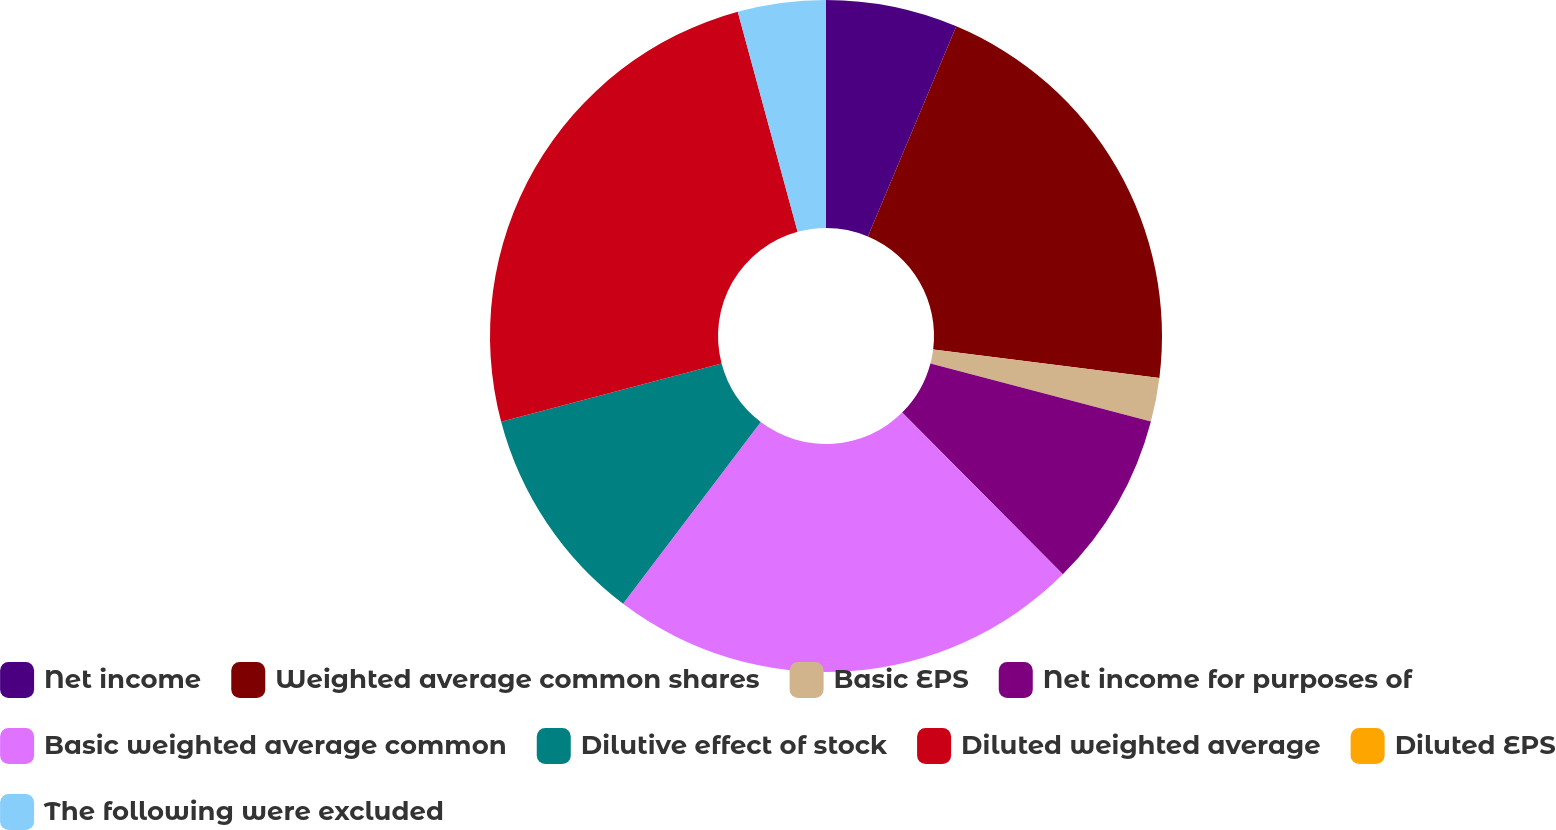Convert chart to OTSL. <chart><loc_0><loc_0><loc_500><loc_500><pie_chart><fcel>Net income<fcel>Weighted average common shares<fcel>Basic EPS<fcel>Net income for purposes of<fcel>Basic weighted average common<fcel>Dilutive effect of stock<fcel>Diluted weighted average<fcel>Diluted EPS<fcel>The following were excluded<nl><fcel>6.34%<fcel>20.65%<fcel>2.11%<fcel>8.45%<fcel>22.77%<fcel>10.57%<fcel>24.88%<fcel>0.0%<fcel>4.23%<nl></chart> 